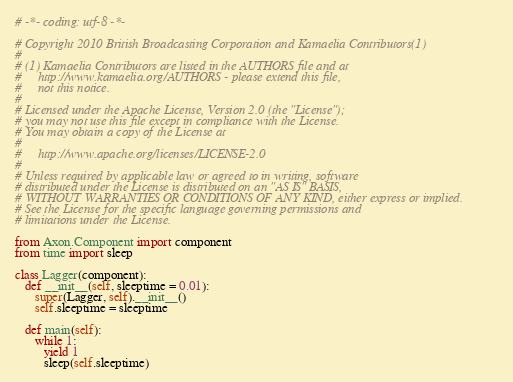Convert code to text. <code><loc_0><loc_0><loc_500><loc_500><_Python_># -*- coding: utf-8 -*-

# Copyright 2010 British Broadcasting Corporation and Kamaelia Contributors(1)
#
# (1) Kamaelia Contributors are listed in the AUTHORS file and at
#     http://www.kamaelia.org/AUTHORS - please extend this file,
#     not this notice.
#
# Licensed under the Apache License, Version 2.0 (the "License");
# you may not use this file except in compliance with the License.
# You may obtain a copy of the License at
#
#     http://www.apache.org/licenses/LICENSE-2.0
#
# Unless required by applicable law or agreed to in writing, software
# distributed under the License is distributed on an "AS IS" BASIS,
# WITHOUT WARRANTIES OR CONDITIONS OF ANY KIND, either express or implied.
# See the License for the specific language governing permissions and
# limitations under the License.

from Axon.Component import component
from time import sleep

class Lagger(component):
   def __init__(self, sleeptime = 0.01):
      super(Lagger, self).__init__()
      self.sleeptime = sleeptime
   
   def main(self):
      while 1:
         yield 1
         sleep(self.sleeptime)
</code> 